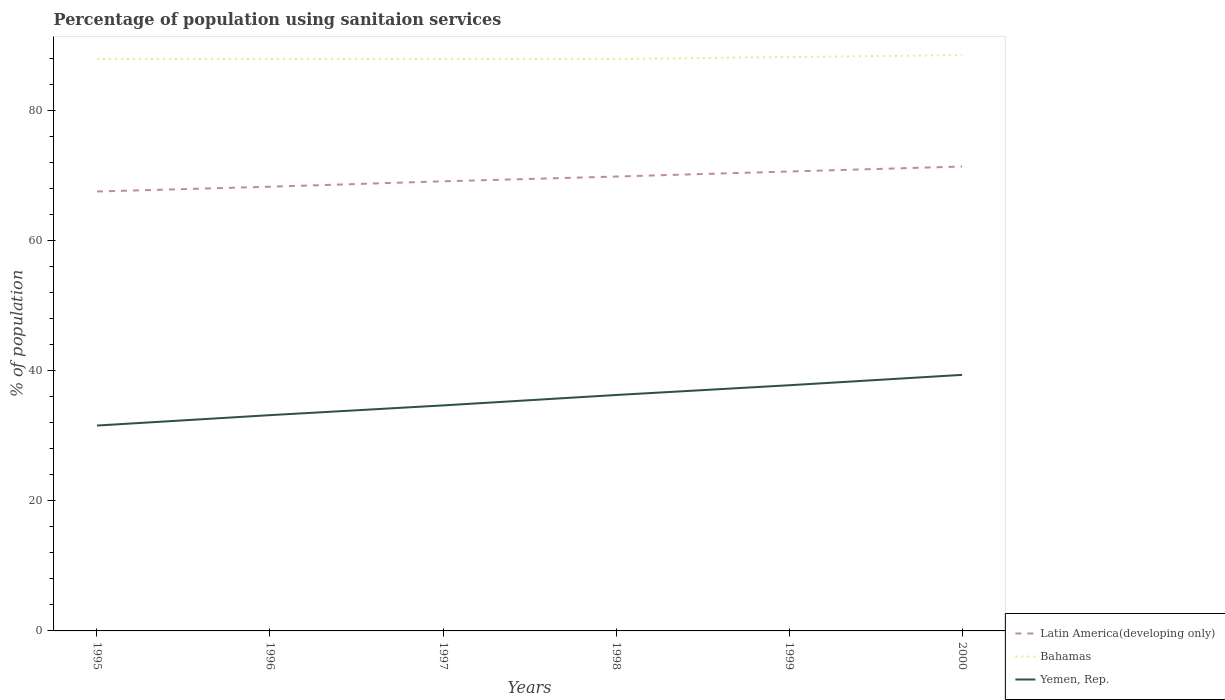Does the line corresponding to Yemen, Rep. intersect with the line corresponding to Bahamas?
Keep it short and to the point. No. Is the number of lines equal to the number of legend labels?
Your answer should be very brief. Yes. Across all years, what is the maximum percentage of population using sanitaion services in Yemen, Rep.?
Offer a very short reply. 31.6. What is the total percentage of population using sanitaion services in Yemen, Rep. in the graph?
Offer a very short reply. -6.2. What is the difference between the highest and the second highest percentage of population using sanitaion services in Latin America(developing only)?
Your answer should be compact. 3.84. What is the difference between the highest and the lowest percentage of population using sanitaion services in Latin America(developing only)?
Provide a succinct answer. 3. How many lines are there?
Give a very brief answer. 3. How many years are there in the graph?
Ensure brevity in your answer.  6. Are the values on the major ticks of Y-axis written in scientific E-notation?
Provide a short and direct response. No. Does the graph contain any zero values?
Your response must be concise. No. Where does the legend appear in the graph?
Keep it short and to the point. Bottom right. What is the title of the graph?
Keep it short and to the point. Percentage of population using sanitaion services. Does "Cyprus" appear as one of the legend labels in the graph?
Provide a succinct answer. No. What is the label or title of the Y-axis?
Your response must be concise. % of population. What is the % of population in Latin America(developing only) in 1995?
Give a very brief answer. 67.61. What is the % of population in Yemen, Rep. in 1995?
Offer a very short reply. 31.6. What is the % of population of Latin America(developing only) in 1996?
Provide a succinct answer. 68.35. What is the % of population of Bahamas in 1996?
Make the answer very short. 88. What is the % of population in Yemen, Rep. in 1996?
Provide a succinct answer. 33.2. What is the % of population of Latin America(developing only) in 1997?
Ensure brevity in your answer.  69.18. What is the % of population of Bahamas in 1997?
Your response must be concise. 88. What is the % of population in Yemen, Rep. in 1997?
Provide a short and direct response. 34.7. What is the % of population of Latin America(developing only) in 1998?
Your response must be concise. 69.91. What is the % of population of Bahamas in 1998?
Your answer should be very brief. 88. What is the % of population in Yemen, Rep. in 1998?
Offer a terse response. 36.3. What is the % of population in Latin America(developing only) in 1999?
Your answer should be compact. 70.69. What is the % of population of Bahamas in 1999?
Offer a very short reply. 88.3. What is the % of population in Yemen, Rep. in 1999?
Give a very brief answer. 37.8. What is the % of population of Latin America(developing only) in 2000?
Make the answer very short. 71.46. What is the % of population in Bahamas in 2000?
Give a very brief answer. 88.6. What is the % of population in Yemen, Rep. in 2000?
Your response must be concise. 39.4. Across all years, what is the maximum % of population in Latin America(developing only)?
Offer a very short reply. 71.46. Across all years, what is the maximum % of population of Bahamas?
Your answer should be compact. 88.6. Across all years, what is the maximum % of population of Yemen, Rep.?
Keep it short and to the point. 39.4. Across all years, what is the minimum % of population in Latin America(developing only)?
Your answer should be very brief. 67.61. Across all years, what is the minimum % of population in Bahamas?
Your answer should be very brief. 88. Across all years, what is the minimum % of population in Yemen, Rep.?
Provide a short and direct response. 31.6. What is the total % of population of Latin America(developing only) in the graph?
Offer a terse response. 417.2. What is the total % of population of Bahamas in the graph?
Your answer should be very brief. 528.9. What is the total % of population in Yemen, Rep. in the graph?
Ensure brevity in your answer.  213. What is the difference between the % of population of Latin America(developing only) in 1995 and that in 1996?
Provide a short and direct response. -0.74. What is the difference between the % of population of Bahamas in 1995 and that in 1996?
Provide a short and direct response. 0. What is the difference between the % of population in Yemen, Rep. in 1995 and that in 1996?
Make the answer very short. -1.6. What is the difference between the % of population in Latin America(developing only) in 1995 and that in 1997?
Provide a short and direct response. -1.57. What is the difference between the % of population in Latin America(developing only) in 1995 and that in 1998?
Offer a terse response. -2.3. What is the difference between the % of population in Yemen, Rep. in 1995 and that in 1998?
Ensure brevity in your answer.  -4.7. What is the difference between the % of population of Latin America(developing only) in 1995 and that in 1999?
Offer a very short reply. -3.08. What is the difference between the % of population of Latin America(developing only) in 1995 and that in 2000?
Keep it short and to the point. -3.84. What is the difference between the % of population in Bahamas in 1995 and that in 2000?
Give a very brief answer. -0.6. What is the difference between the % of population in Yemen, Rep. in 1995 and that in 2000?
Provide a succinct answer. -7.8. What is the difference between the % of population in Latin America(developing only) in 1996 and that in 1997?
Provide a succinct answer. -0.83. What is the difference between the % of population of Latin America(developing only) in 1996 and that in 1998?
Provide a short and direct response. -1.56. What is the difference between the % of population of Bahamas in 1996 and that in 1998?
Provide a succinct answer. 0. What is the difference between the % of population of Yemen, Rep. in 1996 and that in 1998?
Your answer should be compact. -3.1. What is the difference between the % of population in Latin America(developing only) in 1996 and that in 1999?
Ensure brevity in your answer.  -2.34. What is the difference between the % of population of Latin America(developing only) in 1996 and that in 2000?
Your answer should be compact. -3.11. What is the difference between the % of population in Latin America(developing only) in 1997 and that in 1998?
Make the answer very short. -0.73. What is the difference between the % of population of Bahamas in 1997 and that in 1998?
Your answer should be compact. 0. What is the difference between the % of population in Latin America(developing only) in 1997 and that in 1999?
Offer a terse response. -1.51. What is the difference between the % of population of Latin America(developing only) in 1997 and that in 2000?
Give a very brief answer. -2.28. What is the difference between the % of population in Yemen, Rep. in 1997 and that in 2000?
Provide a succinct answer. -4.7. What is the difference between the % of population of Latin America(developing only) in 1998 and that in 1999?
Make the answer very short. -0.78. What is the difference between the % of population in Latin America(developing only) in 1998 and that in 2000?
Provide a succinct answer. -1.54. What is the difference between the % of population in Yemen, Rep. in 1998 and that in 2000?
Your answer should be very brief. -3.1. What is the difference between the % of population of Latin America(developing only) in 1999 and that in 2000?
Keep it short and to the point. -0.77. What is the difference between the % of population in Latin America(developing only) in 1995 and the % of population in Bahamas in 1996?
Your answer should be very brief. -20.39. What is the difference between the % of population in Latin America(developing only) in 1995 and the % of population in Yemen, Rep. in 1996?
Your answer should be compact. 34.41. What is the difference between the % of population of Bahamas in 1995 and the % of population of Yemen, Rep. in 1996?
Your answer should be compact. 54.8. What is the difference between the % of population of Latin America(developing only) in 1995 and the % of population of Bahamas in 1997?
Keep it short and to the point. -20.39. What is the difference between the % of population in Latin America(developing only) in 1995 and the % of population in Yemen, Rep. in 1997?
Keep it short and to the point. 32.91. What is the difference between the % of population of Bahamas in 1995 and the % of population of Yemen, Rep. in 1997?
Offer a terse response. 53.3. What is the difference between the % of population of Latin America(developing only) in 1995 and the % of population of Bahamas in 1998?
Provide a short and direct response. -20.39. What is the difference between the % of population of Latin America(developing only) in 1995 and the % of population of Yemen, Rep. in 1998?
Your answer should be compact. 31.31. What is the difference between the % of population in Bahamas in 1995 and the % of population in Yemen, Rep. in 1998?
Offer a terse response. 51.7. What is the difference between the % of population in Latin America(developing only) in 1995 and the % of population in Bahamas in 1999?
Give a very brief answer. -20.69. What is the difference between the % of population in Latin America(developing only) in 1995 and the % of population in Yemen, Rep. in 1999?
Provide a succinct answer. 29.81. What is the difference between the % of population of Bahamas in 1995 and the % of population of Yemen, Rep. in 1999?
Provide a short and direct response. 50.2. What is the difference between the % of population in Latin America(developing only) in 1995 and the % of population in Bahamas in 2000?
Your answer should be compact. -20.99. What is the difference between the % of population of Latin America(developing only) in 1995 and the % of population of Yemen, Rep. in 2000?
Keep it short and to the point. 28.21. What is the difference between the % of population in Bahamas in 1995 and the % of population in Yemen, Rep. in 2000?
Keep it short and to the point. 48.6. What is the difference between the % of population of Latin America(developing only) in 1996 and the % of population of Bahamas in 1997?
Ensure brevity in your answer.  -19.65. What is the difference between the % of population in Latin America(developing only) in 1996 and the % of population in Yemen, Rep. in 1997?
Provide a short and direct response. 33.65. What is the difference between the % of population of Bahamas in 1996 and the % of population of Yemen, Rep. in 1997?
Provide a short and direct response. 53.3. What is the difference between the % of population in Latin America(developing only) in 1996 and the % of population in Bahamas in 1998?
Your response must be concise. -19.65. What is the difference between the % of population of Latin America(developing only) in 1996 and the % of population of Yemen, Rep. in 1998?
Give a very brief answer. 32.05. What is the difference between the % of population in Bahamas in 1996 and the % of population in Yemen, Rep. in 1998?
Your answer should be compact. 51.7. What is the difference between the % of population in Latin America(developing only) in 1996 and the % of population in Bahamas in 1999?
Provide a succinct answer. -19.95. What is the difference between the % of population in Latin America(developing only) in 1996 and the % of population in Yemen, Rep. in 1999?
Provide a short and direct response. 30.55. What is the difference between the % of population of Bahamas in 1996 and the % of population of Yemen, Rep. in 1999?
Your answer should be very brief. 50.2. What is the difference between the % of population in Latin America(developing only) in 1996 and the % of population in Bahamas in 2000?
Make the answer very short. -20.25. What is the difference between the % of population of Latin America(developing only) in 1996 and the % of population of Yemen, Rep. in 2000?
Your answer should be compact. 28.95. What is the difference between the % of population in Bahamas in 1996 and the % of population in Yemen, Rep. in 2000?
Give a very brief answer. 48.6. What is the difference between the % of population in Latin America(developing only) in 1997 and the % of population in Bahamas in 1998?
Keep it short and to the point. -18.82. What is the difference between the % of population of Latin America(developing only) in 1997 and the % of population of Yemen, Rep. in 1998?
Your answer should be compact. 32.88. What is the difference between the % of population of Bahamas in 1997 and the % of population of Yemen, Rep. in 1998?
Provide a succinct answer. 51.7. What is the difference between the % of population of Latin America(developing only) in 1997 and the % of population of Bahamas in 1999?
Ensure brevity in your answer.  -19.12. What is the difference between the % of population of Latin America(developing only) in 1997 and the % of population of Yemen, Rep. in 1999?
Keep it short and to the point. 31.38. What is the difference between the % of population in Bahamas in 1997 and the % of population in Yemen, Rep. in 1999?
Offer a terse response. 50.2. What is the difference between the % of population in Latin America(developing only) in 1997 and the % of population in Bahamas in 2000?
Provide a short and direct response. -19.42. What is the difference between the % of population of Latin America(developing only) in 1997 and the % of population of Yemen, Rep. in 2000?
Ensure brevity in your answer.  29.78. What is the difference between the % of population of Bahamas in 1997 and the % of population of Yemen, Rep. in 2000?
Your answer should be very brief. 48.6. What is the difference between the % of population of Latin America(developing only) in 1998 and the % of population of Bahamas in 1999?
Ensure brevity in your answer.  -18.39. What is the difference between the % of population in Latin America(developing only) in 1998 and the % of population in Yemen, Rep. in 1999?
Provide a succinct answer. 32.11. What is the difference between the % of population in Bahamas in 1998 and the % of population in Yemen, Rep. in 1999?
Offer a very short reply. 50.2. What is the difference between the % of population in Latin America(developing only) in 1998 and the % of population in Bahamas in 2000?
Your answer should be very brief. -18.69. What is the difference between the % of population in Latin America(developing only) in 1998 and the % of population in Yemen, Rep. in 2000?
Provide a short and direct response. 30.51. What is the difference between the % of population in Bahamas in 1998 and the % of population in Yemen, Rep. in 2000?
Your answer should be very brief. 48.6. What is the difference between the % of population of Latin America(developing only) in 1999 and the % of population of Bahamas in 2000?
Offer a terse response. -17.91. What is the difference between the % of population in Latin America(developing only) in 1999 and the % of population in Yemen, Rep. in 2000?
Make the answer very short. 31.29. What is the difference between the % of population in Bahamas in 1999 and the % of population in Yemen, Rep. in 2000?
Keep it short and to the point. 48.9. What is the average % of population of Latin America(developing only) per year?
Your answer should be compact. 69.53. What is the average % of population of Bahamas per year?
Offer a terse response. 88.15. What is the average % of population in Yemen, Rep. per year?
Your response must be concise. 35.5. In the year 1995, what is the difference between the % of population of Latin America(developing only) and % of population of Bahamas?
Your answer should be compact. -20.39. In the year 1995, what is the difference between the % of population of Latin America(developing only) and % of population of Yemen, Rep.?
Provide a succinct answer. 36.01. In the year 1995, what is the difference between the % of population in Bahamas and % of population in Yemen, Rep.?
Your answer should be very brief. 56.4. In the year 1996, what is the difference between the % of population in Latin America(developing only) and % of population in Bahamas?
Offer a very short reply. -19.65. In the year 1996, what is the difference between the % of population in Latin America(developing only) and % of population in Yemen, Rep.?
Make the answer very short. 35.15. In the year 1996, what is the difference between the % of population in Bahamas and % of population in Yemen, Rep.?
Provide a succinct answer. 54.8. In the year 1997, what is the difference between the % of population in Latin America(developing only) and % of population in Bahamas?
Ensure brevity in your answer.  -18.82. In the year 1997, what is the difference between the % of population in Latin America(developing only) and % of population in Yemen, Rep.?
Your answer should be very brief. 34.48. In the year 1997, what is the difference between the % of population of Bahamas and % of population of Yemen, Rep.?
Ensure brevity in your answer.  53.3. In the year 1998, what is the difference between the % of population of Latin America(developing only) and % of population of Bahamas?
Offer a very short reply. -18.09. In the year 1998, what is the difference between the % of population of Latin America(developing only) and % of population of Yemen, Rep.?
Make the answer very short. 33.61. In the year 1998, what is the difference between the % of population of Bahamas and % of population of Yemen, Rep.?
Your answer should be very brief. 51.7. In the year 1999, what is the difference between the % of population in Latin America(developing only) and % of population in Bahamas?
Provide a succinct answer. -17.61. In the year 1999, what is the difference between the % of population of Latin America(developing only) and % of population of Yemen, Rep.?
Offer a very short reply. 32.89. In the year 1999, what is the difference between the % of population in Bahamas and % of population in Yemen, Rep.?
Provide a succinct answer. 50.5. In the year 2000, what is the difference between the % of population of Latin America(developing only) and % of population of Bahamas?
Offer a terse response. -17.14. In the year 2000, what is the difference between the % of population in Latin America(developing only) and % of population in Yemen, Rep.?
Your answer should be very brief. 32.06. In the year 2000, what is the difference between the % of population in Bahamas and % of population in Yemen, Rep.?
Ensure brevity in your answer.  49.2. What is the ratio of the % of population in Latin America(developing only) in 1995 to that in 1996?
Provide a short and direct response. 0.99. What is the ratio of the % of population in Yemen, Rep. in 1995 to that in 1996?
Your answer should be very brief. 0.95. What is the ratio of the % of population of Latin America(developing only) in 1995 to that in 1997?
Make the answer very short. 0.98. What is the ratio of the % of population in Bahamas in 1995 to that in 1997?
Ensure brevity in your answer.  1. What is the ratio of the % of population in Yemen, Rep. in 1995 to that in 1997?
Keep it short and to the point. 0.91. What is the ratio of the % of population of Latin America(developing only) in 1995 to that in 1998?
Give a very brief answer. 0.97. What is the ratio of the % of population of Bahamas in 1995 to that in 1998?
Keep it short and to the point. 1. What is the ratio of the % of population in Yemen, Rep. in 1995 to that in 1998?
Offer a terse response. 0.87. What is the ratio of the % of population of Latin America(developing only) in 1995 to that in 1999?
Give a very brief answer. 0.96. What is the ratio of the % of population in Yemen, Rep. in 1995 to that in 1999?
Provide a short and direct response. 0.84. What is the ratio of the % of population of Latin America(developing only) in 1995 to that in 2000?
Offer a very short reply. 0.95. What is the ratio of the % of population in Yemen, Rep. in 1995 to that in 2000?
Your answer should be compact. 0.8. What is the ratio of the % of population of Bahamas in 1996 to that in 1997?
Make the answer very short. 1. What is the ratio of the % of population in Yemen, Rep. in 1996 to that in 1997?
Offer a terse response. 0.96. What is the ratio of the % of population in Latin America(developing only) in 1996 to that in 1998?
Your response must be concise. 0.98. What is the ratio of the % of population of Yemen, Rep. in 1996 to that in 1998?
Ensure brevity in your answer.  0.91. What is the ratio of the % of population of Latin America(developing only) in 1996 to that in 1999?
Offer a terse response. 0.97. What is the ratio of the % of population of Yemen, Rep. in 1996 to that in 1999?
Keep it short and to the point. 0.88. What is the ratio of the % of population of Latin America(developing only) in 1996 to that in 2000?
Your response must be concise. 0.96. What is the ratio of the % of population of Bahamas in 1996 to that in 2000?
Provide a succinct answer. 0.99. What is the ratio of the % of population in Yemen, Rep. in 1996 to that in 2000?
Ensure brevity in your answer.  0.84. What is the ratio of the % of population of Latin America(developing only) in 1997 to that in 1998?
Keep it short and to the point. 0.99. What is the ratio of the % of population in Bahamas in 1997 to that in 1998?
Offer a terse response. 1. What is the ratio of the % of population in Yemen, Rep. in 1997 to that in 1998?
Your answer should be very brief. 0.96. What is the ratio of the % of population in Latin America(developing only) in 1997 to that in 1999?
Provide a succinct answer. 0.98. What is the ratio of the % of population in Bahamas in 1997 to that in 1999?
Your response must be concise. 1. What is the ratio of the % of population in Yemen, Rep. in 1997 to that in 1999?
Give a very brief answer. 0.92. What is the ratio of the % of population in Latin America(developing only) in 1997 to that in 2000?
Provide a succinct answer. 0.97. What is the ratio of the % of population in Yemen, Rep. in 1997 to that in 2000?
Make the answer very short. 0.88. What is the ratio of the % of population of Bahamas in 1998 to that in 1999?
Provide a succinct answer. 1. What is the ratio of the % of population in Yemen, Rep. in 1998 to that in 1999?
Give a very brief answer. 0.96. What is the ratio of the % of population in Latin America(developing only) in 1998 to that in 2000?
Keep it short and to the point. 0.98. What is the ratio of the % of population in Bahamas in 1998 to that in 2000?
Your answer should be very brief. 0.99. What is the ratio of the % of population of Yemen, Rep. in 1998 to that in 2000?
Give a very brief answer. 0.92. What is the ratio of the % of population of Latin America(developing only) in 1999 to that in 2000?
Your answer should be compact. 0.99. What is the ratio of the % of population of Bahamas in 1999 to that in 2000?
Ensure brevity in your answer.  1. What is the ratio of the % of population in Yemen, Rep. in 1999 to that in 2000?
Offer a terse response. 0.96. What is the difference between the highest and the second highest % of population of Latin America(developing only)?
Offer a very short reply. 0.77. What is the difference between the highest and the second highest % of population in Bahamas?
Provide a succinct answer. 0.3. What is the difference between the highest and the second highest % of population in Yemen, Rep.?
Give a very brief answer. 1.6. What is the difference between the highest and the lowest % of population of Latin America(developing only)?
Offer a terse response. 3.84. What is the difference between the highest and the lowest % of population of Yemen, Rep.?
Make the answer very short. 7.8. 